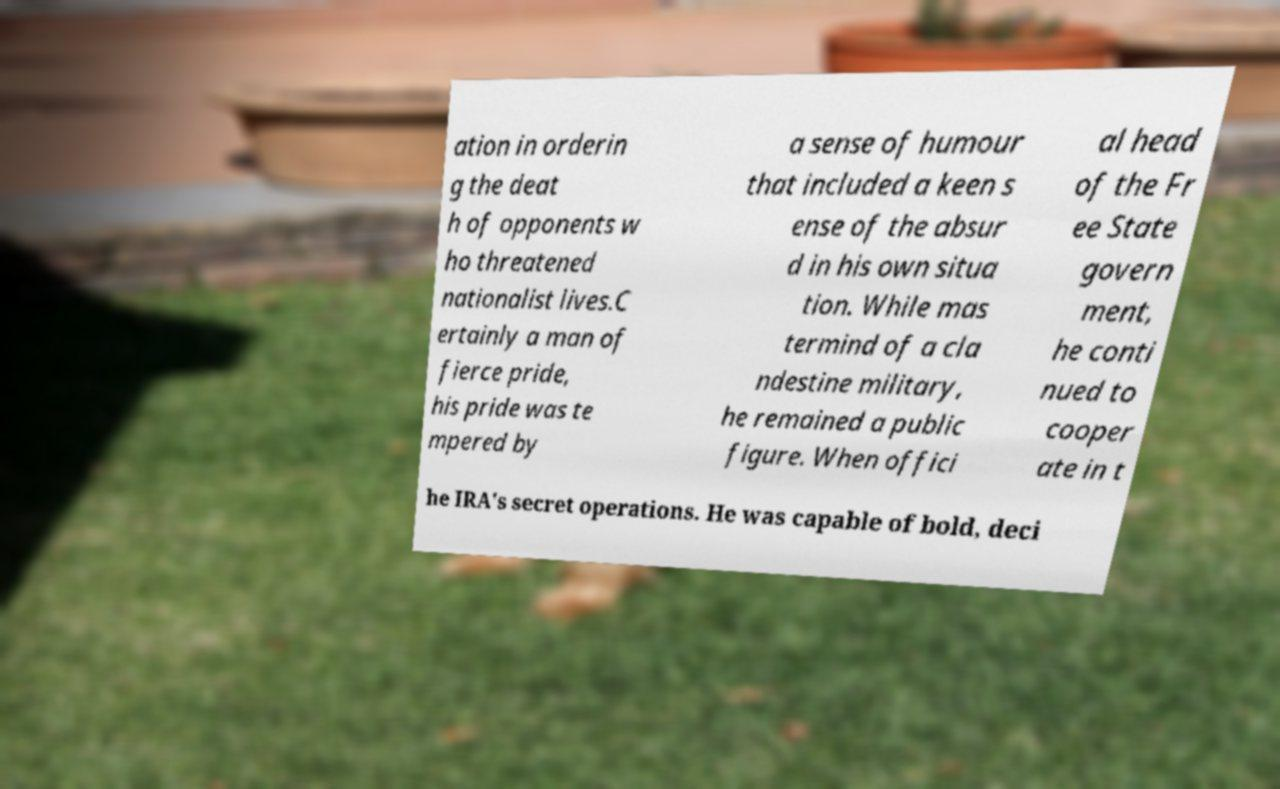What messages or text are displayed in this image? I need them in a readable, typed format. ation in orderin g the deat h of opponents w ho threatened nationalist lives.C ertainly a man of fierce pride, his pride was te mpered by a sense of humour that included a keen s ense of the absur d in his own situa tion. While mas termind of a cla ndestine military, he remained a public figure. When offici al head of the Fr ee State govern ment, he conti nued to cooper ate in t he IRA's secret operations. He was capable of bold, deci 